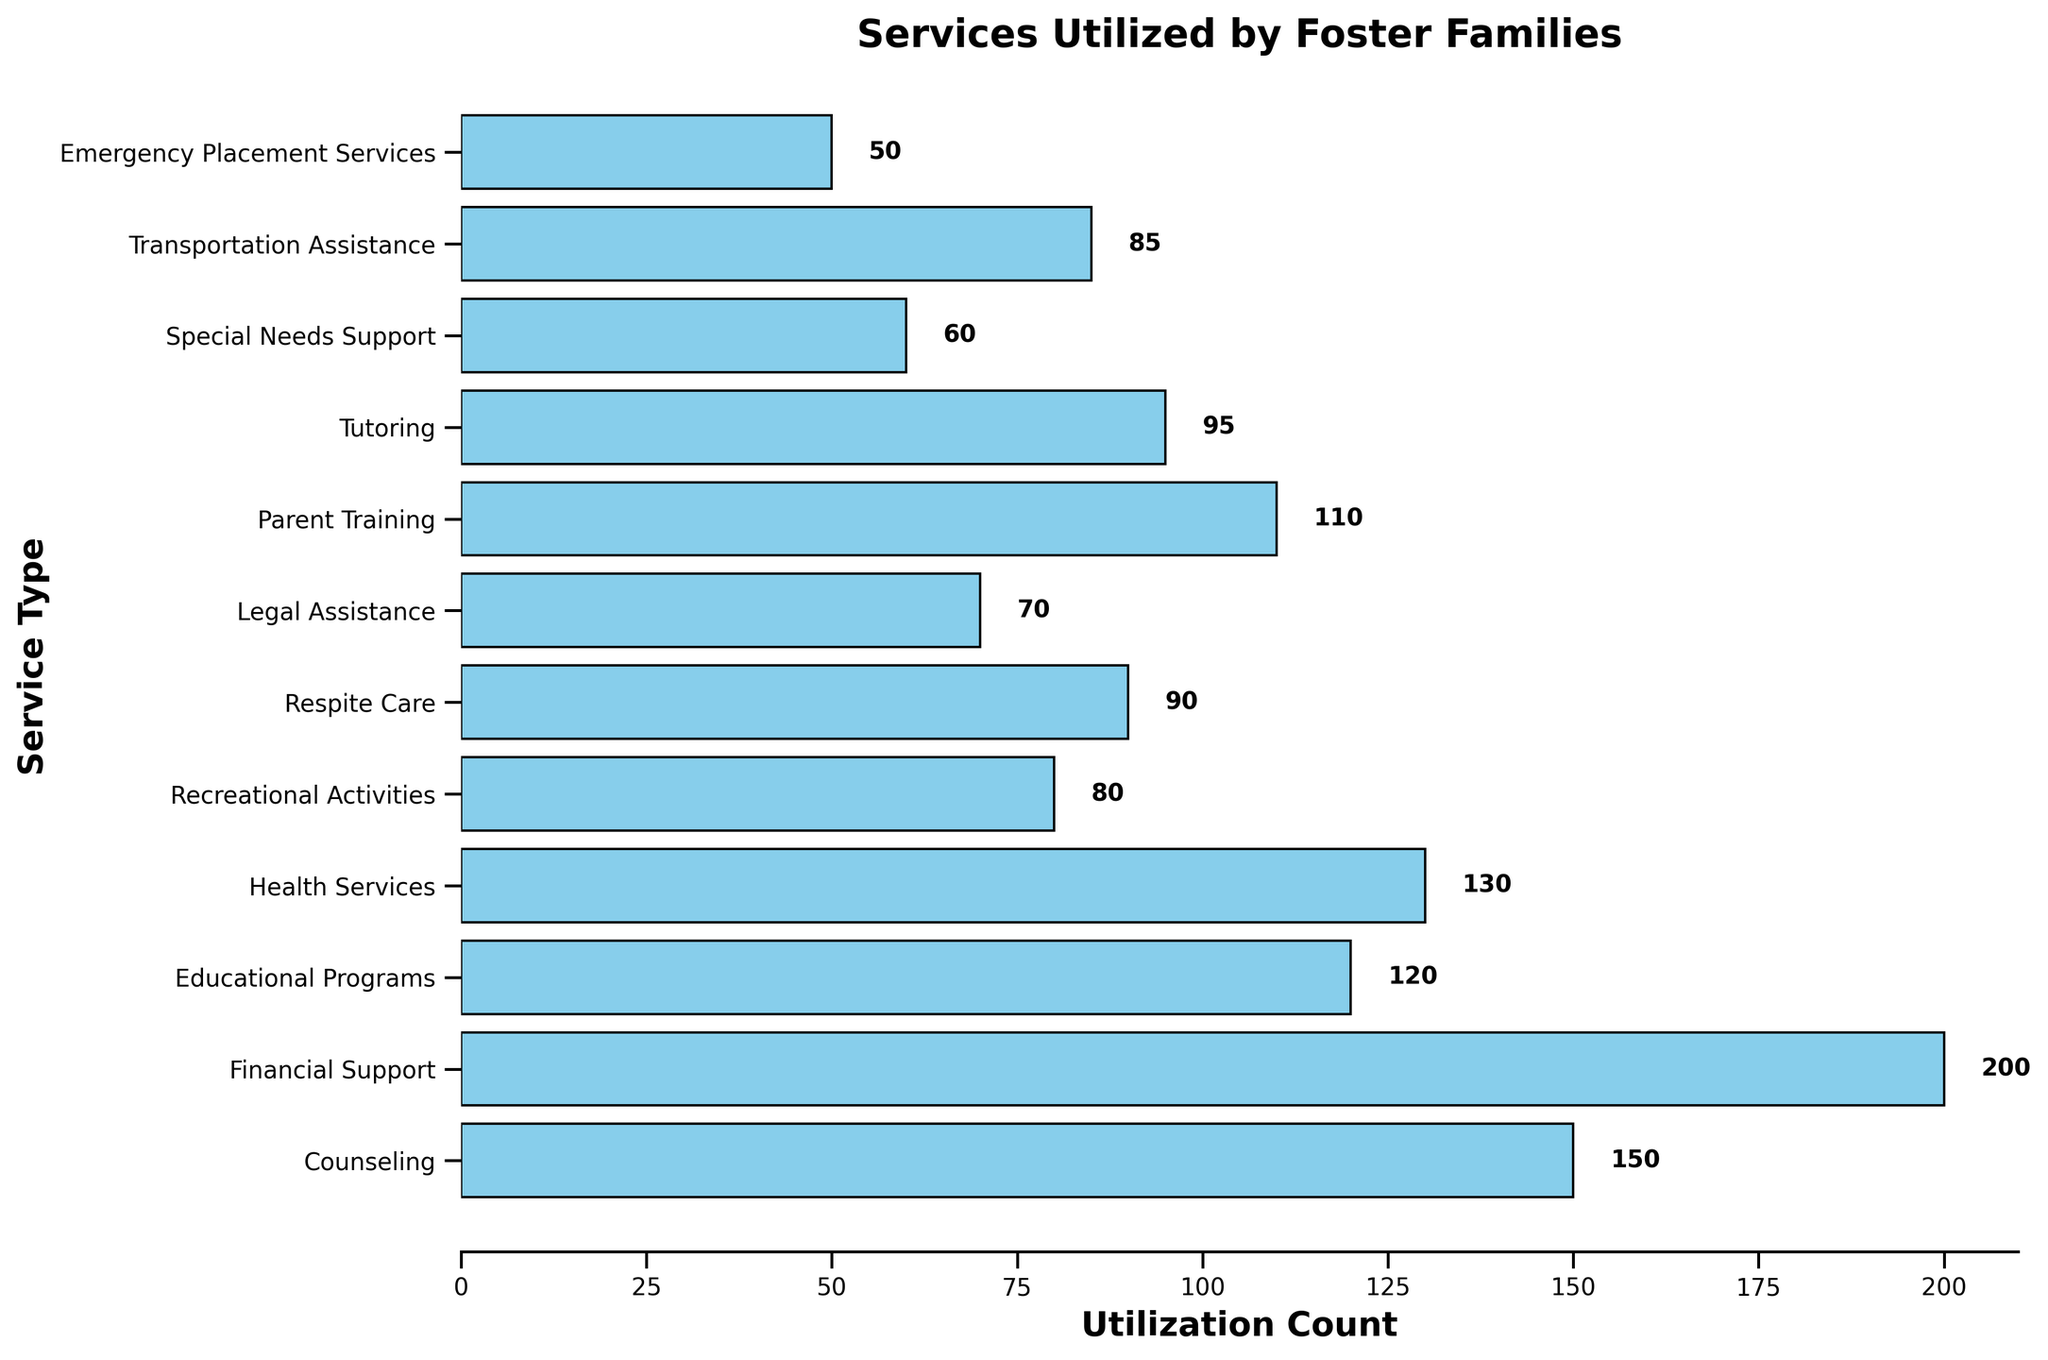Which service is utilized the most by foster families? By looking at the lengths of the bars, the longest bar indicates the service with the highest count of utilization. Financial Support has the longest bar.
Answer: Financial Support Which service is utilized the least by foster families? By looking at the lengths of the bars, the shortest bar indicates the service with the lowest count of utilization. Emergency Placement Services has the shortest bar.
Answer: Emergency Placement Services What is the total utilization count for Counseling and Health Services combined? Add the utilization counts for Counseling (150) and Health Services (130). So, 150 + 130 = 280.
Answer: 280 How much more is Financial Support utilized compared to Special Needs Support? Subtract the utilization count of Special Needs Support (60) from Financial Support (200). So, 200 - 60 = 140.
Answer: 140 Which two services have the closest utilization counts? By looking at the lengths of the bars, Respite Care (90) and Tutoring (95) have similar lengths indicating close utilization counts.
Answer: Respite Care and Tutoring Rank the top three most utilized services. By looking at the lengths of the bars, the three services with the longest bars are Financial Support (200), Counseling (150), and Health Services (130).
Answer: Financial Support, Counseling, Health Services What is the average utilization count for Educational Programs, Recreational Activities, and Legal Assistance? Add the utilization counts for Educational Programs (120), Recreational Activities (80), and Legal Assistance (70) and then divide by the number of services (3). So, (120 + 80 + 70) / 3 = 270 / 3 = 90.
Answer: 90 Are Tutoring and Recreational Activities utilized more or less than 200 times combined? Add the utilization counts for Tutoring (95) and Recreational Activities (80). So, 95 + 80 = 175, which is less than 200.
Answer: Less than 200 times Which service has a utilization count closest to 100? By looking at the lengths of the bars, Parent Training has a utilization count (110) closest to 100.
Answer: Parent Training 